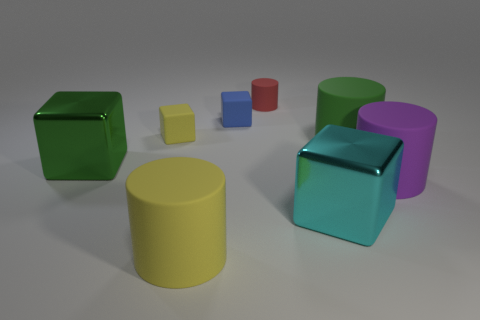How many things are both on the left side of the purple matte object and behind the cyan cube?
Give a very brief answer. 5. What color is the cylinder behind the green thing behind the large metal object left of the tiny cylinder?
Make the answer very short. Red. What number of other objects are there of the same shape as the red thing?
Keep it short and to the point. 3. Are there any small matte blocks that are behind the tiny rubber object that is behind the blue matte cube?
Your response must be concise. No. How many matte objects are either large purple things or red things?
Offer a very short reply. 2. There is a block that is in front of the large green cylinder and to the left of the red rubber thing; what material is it?
Ensure brevity in your answer.  Metal. There is a object that is in front of the metallic thing to the right of the big green metal block; are there any blue rubber blocks behind it?
Provide a short and direct response. Yes. Is there any other thing that is made of the same material as the cyan thing?
Keep it short and to the point. Yes. There is a tiny red thing that is the same material as the tiny blue thing; what is its shape?
Offer a terse response. Cylinder. Is the number of small matte cubes on the right side of the small red object less than the number of big yellow objects on the left side of the large yellow rubber object?
Provide a short and direct response. No. 